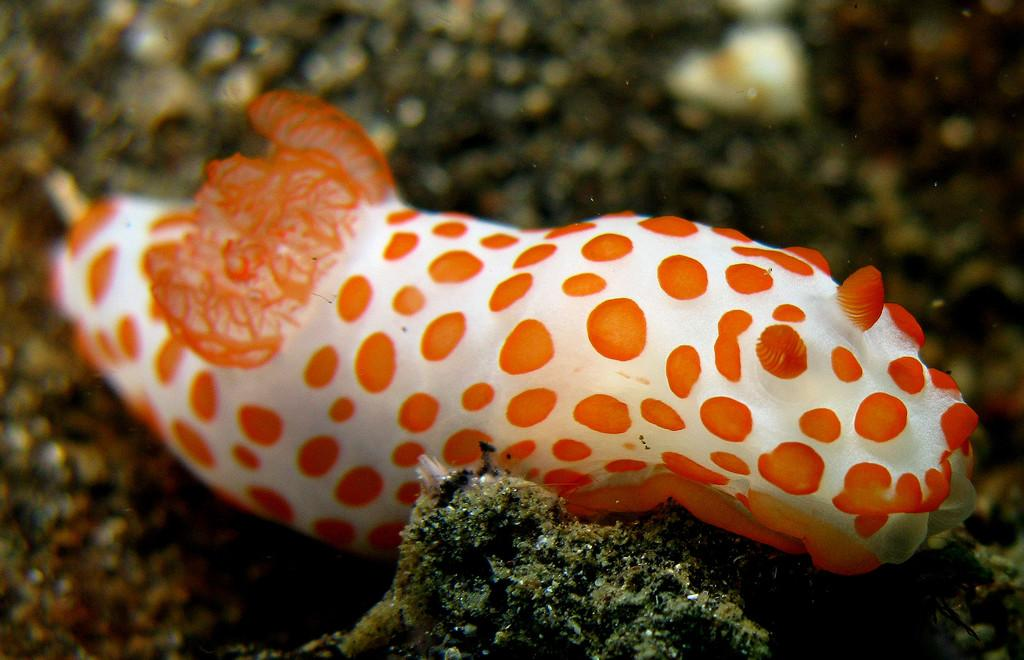What is the main subject of the image? The main subject of the image is a water body. How is the water body shaped? The water body resembles a fish. What colors can be seen in the water body? The water body has orange and white colors. Can you describe the background of the image? The background of the image is blurred. How many representatives are present in the image? There are no representatives present in the image; it features a water body shaped like a fish with orange and white colors against a blurred background. 